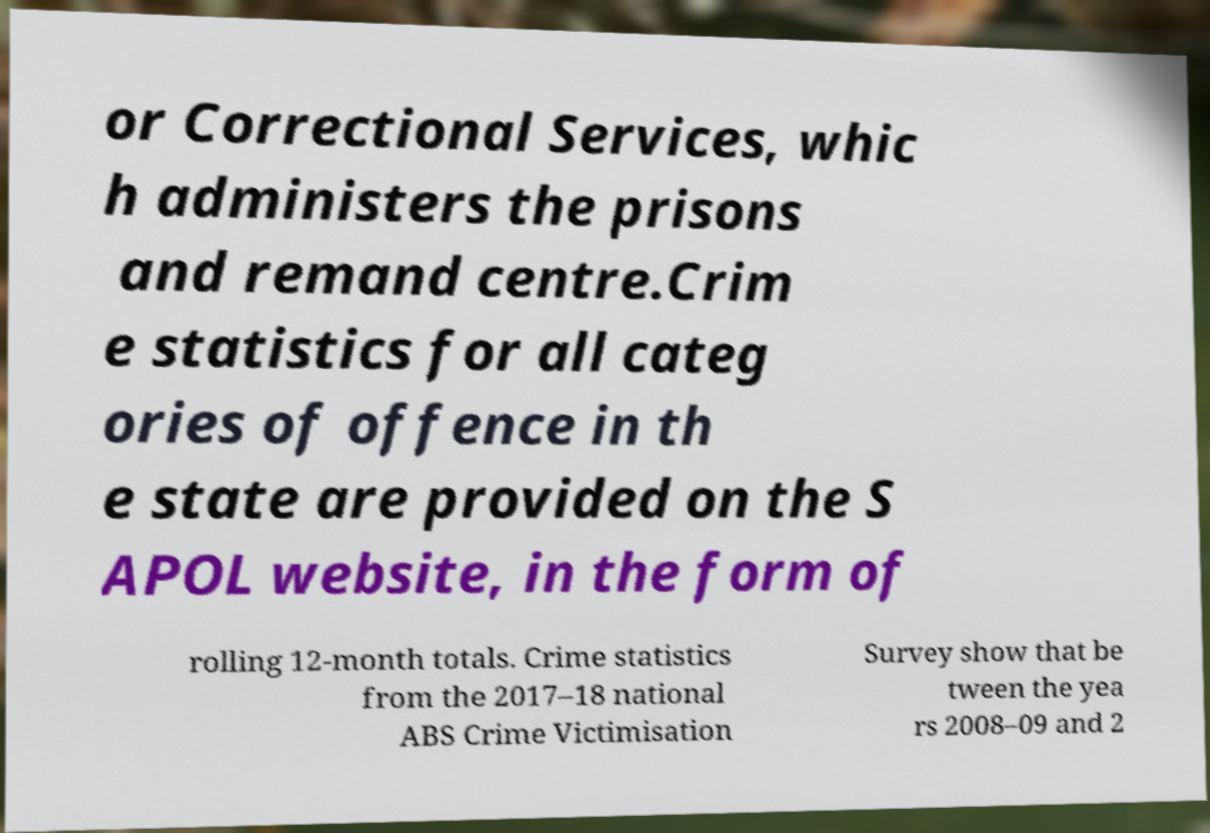I need the written content from this picture converted into text. Can you do that? or Correctional Services, whic h administers the prisons and remand centre.Crim e statistics for all categ ories of offence in th e state are provided on the S APOL website, in the form of rolling 12-month totals. Crime statistics from the 2017–18 national ABS Crime Victimisation Survey show that be tween the yea rs 2008–09 and 2 